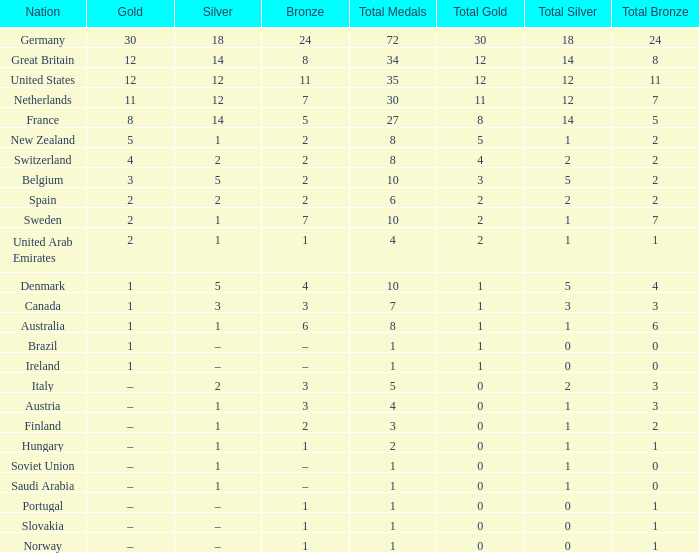What is gold, when silver is 5, and when state is belgium? 3.0. 